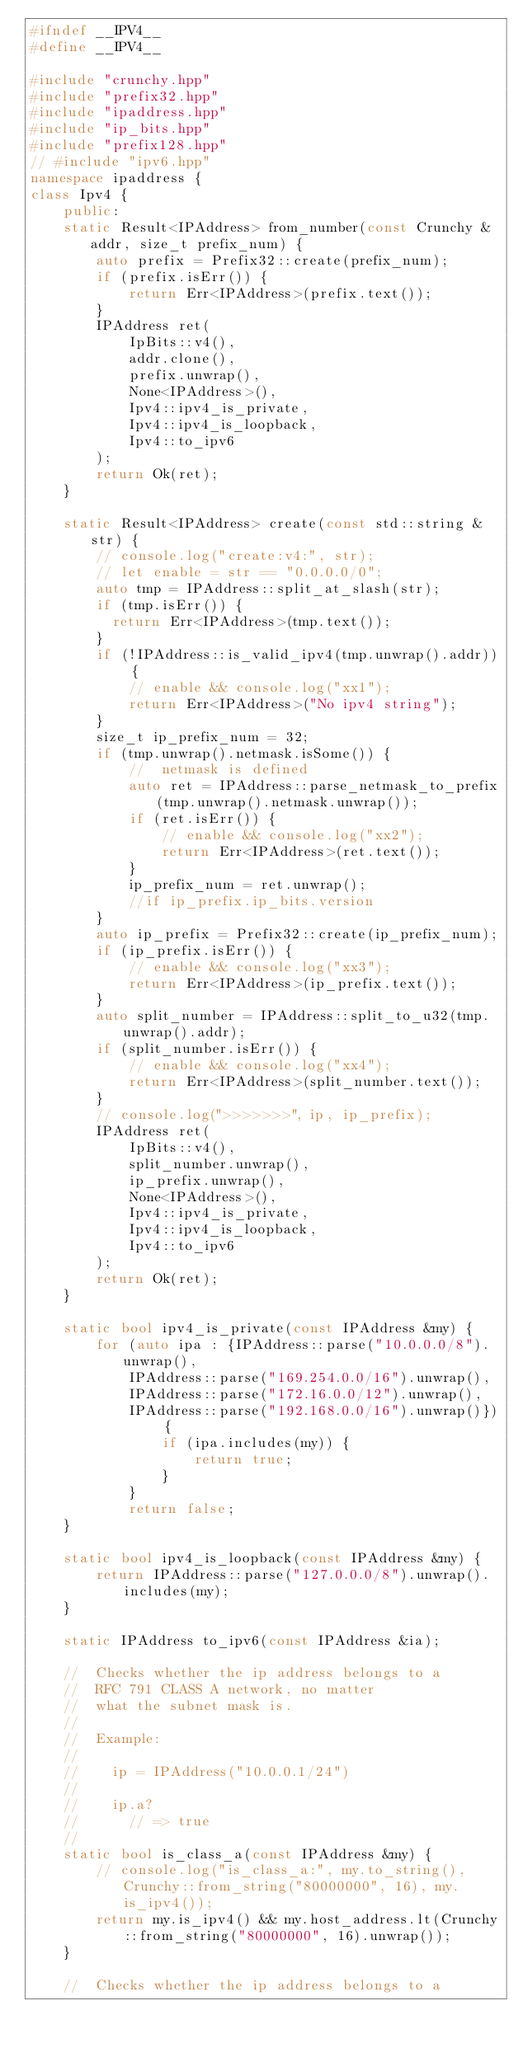Convert code to text. <code><loc_0><loc_0><loc_500><loc_500><_C++_>#ifndef __IPV4__
#define __IPV4__

#include "crunchy.hpp"
#include "prefix32.hpp"
#include "ipaddress.hpp"
#include "ip_bits.hpp"
#include "prefix128.hpp"
// #include "ipv6.hpp"
namespace ipaddress {
class Ipv4 {
    public:
    static Result<IPAddress> from_number(const Crunchy &addr, size_t prefix_num) {
        auto prefix = Prefix32::create(prefix_num);
        if (prefix.isErr()) {
            return Err<IPAddress>(prefix.text());
        }
        IPAddress ret(
            IpBits::v4(),
            addr.clone(),
            prefix.unwrap(),
            None<IPAddress>(),
            Ipv4::ipv4_is_private,
            Ipv4::ipv4_is_loopback,
            Ipv4::to_ipv6
        );
        return Ok(ret);
    }

    static Result<IPAddress> create(const std::string &str) {
        // console.log("create:v4:", str);
        // let enable = str == "0.0.0.0/0";
        auto tmp = IPAddress::split_at_slash(str);
        if (tmp.isErr()) {
          return Err<IPAddress>(tmp.text());
        }
        if (!IPAddress::is_valid_ipv4(tmp.unwrap().addr)) {
            // enable && console.log("xx1");
            return Err<IPAddress>("No ipv4 string");
        }
        size_t ip_prefix_num = 32;
        if (tmp.unwrap().netmask.isSome()) {
            //  netmask is defined
            auto ret = IPAddress::parse_netmask_to_prefix(tmp.unwrap().netmask.unwrap());
            if (ret.isErr()) {
                // enable && console.log("xx2");
                return Err<IPAddress>(ret.text());
            }
            ip_prefix_num = ret.unwrap();
            //if ip_prefix.ip_bits.version
        }
        auto ip_prefix = Prefix32::create(ip_prefix_num);
        if (ip_prefix.isErr()) {
            // enable && console.log("xx3");
            return Err<IPAddress>(ip_prefix.text());
        }
        auto split_number = IPAddress::split_to_u32(tmp.unwrap().addr);
        if (split_number.isErr()) {
            // enable && console.log("xx4");
            return Err<IPAddress>(split_number.text());
        }
        // console.log(">>>>>>>", ip, ip_prefix);
        IPAddress ret(
            IpBits::v4(),
            split_number.unwrap(),
            ip_prefix.unwrap(),
            None<IPAddress>(),
            Ipv4::ipv4_is_private,
            Ipv4::ipv4_is_loopback,
            Ipv4::to_ipv6
        );
        return Ok(ret);
    }

    static bool ipv4_is_private(const IPAddress &my) {
        for (auto ipa : {IPAddress::parse("10.0.0.0/8").unwrap(),
            IPAddress::parse("169.254.0.0/16").unwrap(),
            IPAddress::parse("172.16.0.0/12").unwrap(),
            IPAddress::parse("192.168.0.0/16").unwrap()}) {
                if (ipa.includes(my)) {
                    return true;
                }
            }
            return false;
    }

    static bool ipv4_is_loopback(const IPAddress &my) {
        return IPAddress::parse("127.0.0.0/8").unwrap().includes(my);
    }

    static IPAddress to_ipv6(const IPAddress &ia);

    //  Checks whether the ip address belongs to a
    //  RFC 791 CLASS A network, no matter
    //  what the subnet mask is.
    //
    //  Example:
    //
    //    ip = IPAddress("10.0.0.1/24")
    //
    //    ip.a?
    //      // => true
    //
    static bool is_class_a(const IPAddress &my) {
        // console.log("is_class_a:", my.to_string(), Crunchy::from_string("80000000", 16), my.is_ipv4());
        return my.is_ipv4() && my.host_address.lt(Crunchy::from_string("80000000", 16).unwrap());
    }

    //  Checks whether the ip address belongs to a</code> 